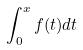Convert formula to latex. <formula><loc_0><loc_0><loc_500><loc_500>\int _ { 0 } ^ { x } f ( t ) d t</formula> 